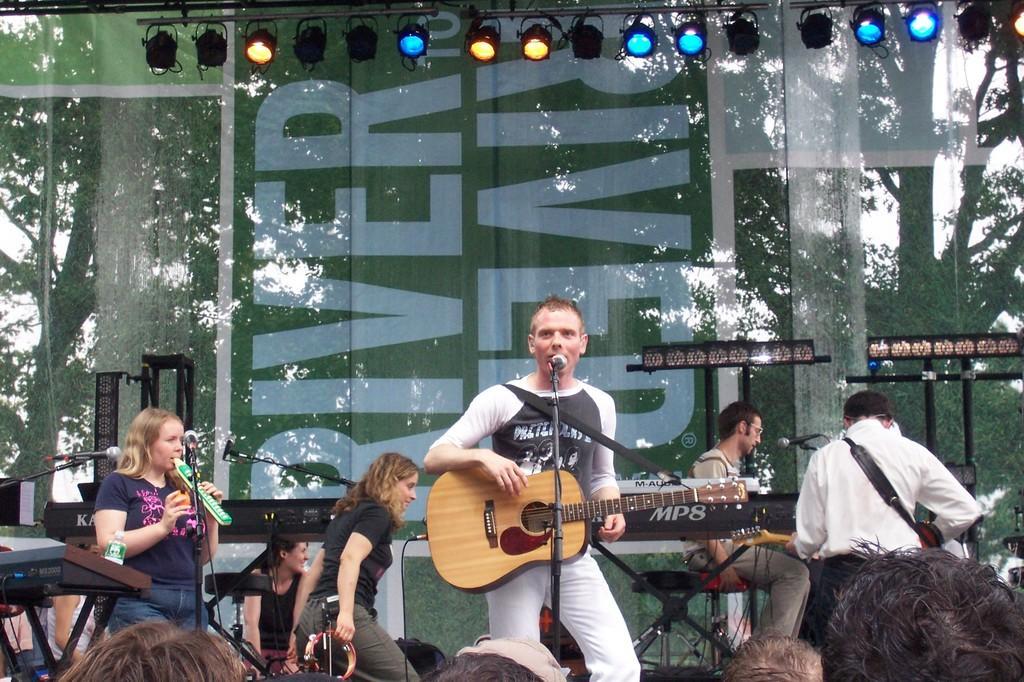Could you give a brief overview of what you see in this image? Here in this picture we can see six people are on the stage. The front man is playing guitar and singing the song in front of the mic. The right side girl is standing. And the girl with the black dress is walking. We can see lights on the top. Behind them there is a tree. We can see some people are standing. 